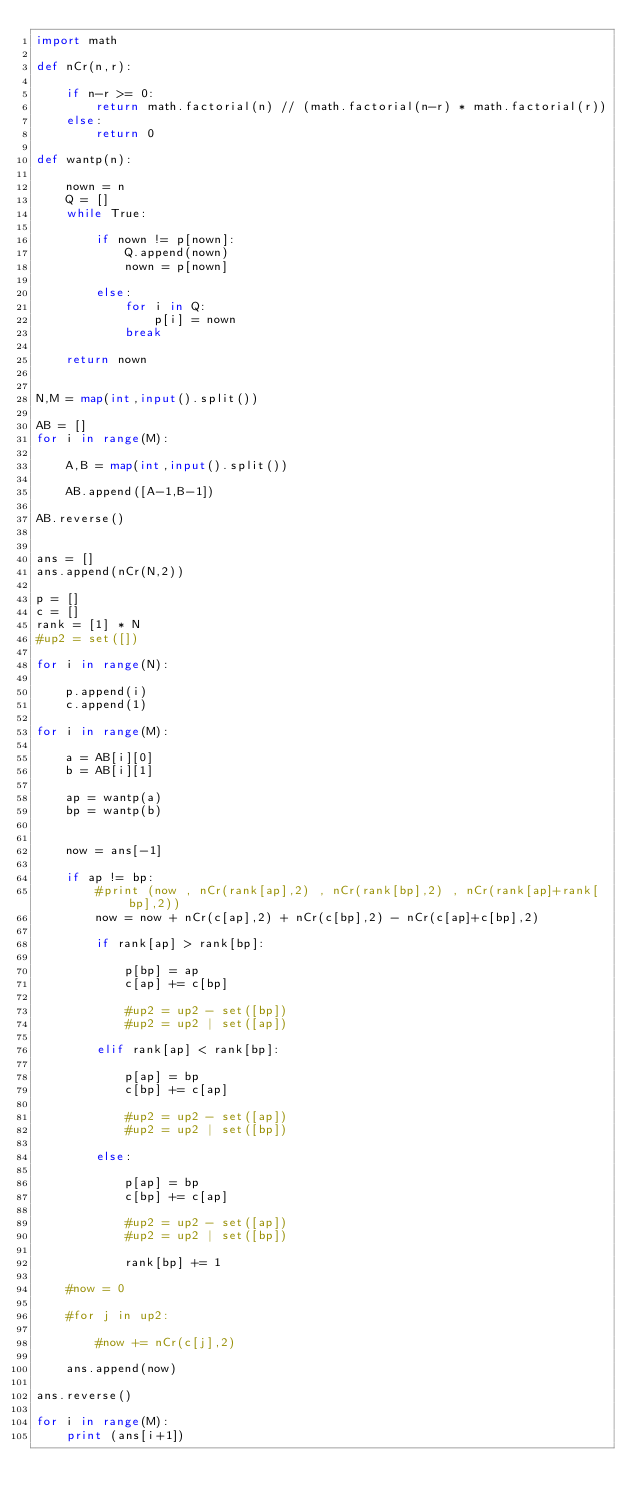Convert code to text. <code><loc_0><loc_0><loc_500><loc_500><_Python_>import math

def nCr(n,r):

    if n-r >= 0:
        return math.factorial(n) // (math.factorial(n-r) * math.factorial(r))
    else:
        return 0

def wantp(n):

    nown = n
    Q = []
    while True:

        if nown != p[nown]:
            Q.append(nown)
            nown = p[nown]

        else:
            for i in Q:
                p[i] = nown
            break

    return nown


N,M = map(int,input().split())

AB = []
for i in range(M):

    A,B = map(int,input().split())

    AB.append([A-1,B-1])

AB.reverse()


ans = []
ans.append(nCr(N,2))

p = []
c = []
rank = [1] * N
#up2 = set([])

for i in range(N):

    p.append(i)
    c.append(1)

for i in range(M):

    a = AB[i][0]
    b = AB[i][1]

    ap = wantp(a)
    bp = wantp(b)


    now = ans[-1]

    if ap != bp:
        #print (now , nCr(rank[ap],2) , nCr(rank[bp],2) , nCr(rank[ap]+rank[bp],2))
        now = now + nCr(c[ap],2) + nCr(c[bp],2) - nCr(c[ap]+c[bp],2)

        if rank[ap] > rank[bp]:

            p[bp] = ap
            c[ap] += c[bp]

            #up2 = up2 - set([bp])
            #up2 = up2 | set([ap])

        elif rank[ap] < rank[bp]:

            p[ap] = bp
            c[bp] += c[ap]

            #up2 = up2 - set([ap])
            #up2 = up2 | set([bp])

        else:

            p[ap] = bp
            c[bp] += c[ap]

            #up2 = up2 - set([ap])
            #up2 = up2 | set([bp])

            rank[bp] += 1

    #now = 0

    #for j in up2:

        #now += nCr(c[j],2)

    ans.append(now)

ans.reverse()

for i in range(M):
    print (ans[i+1])</code> 